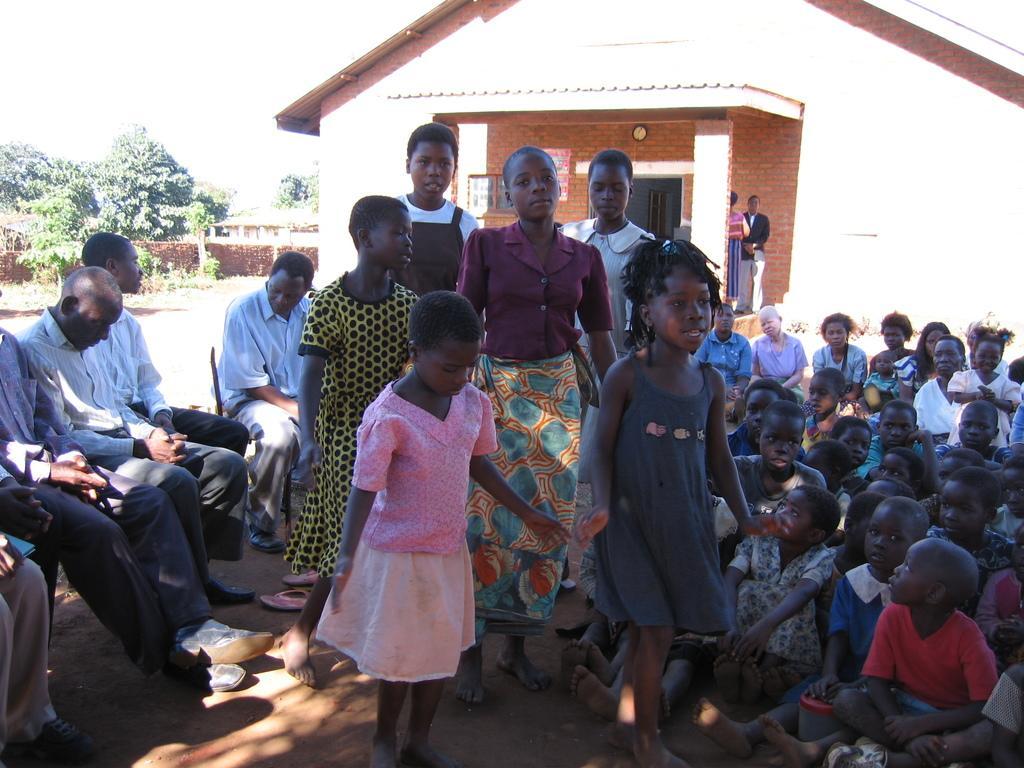Describe this image in one or two sentences. In the image there are a lot of people, on the right side many of them were sitting on the floor and few people were standing on the left side. Behind the people there is a house and on the left side there are few trees. 